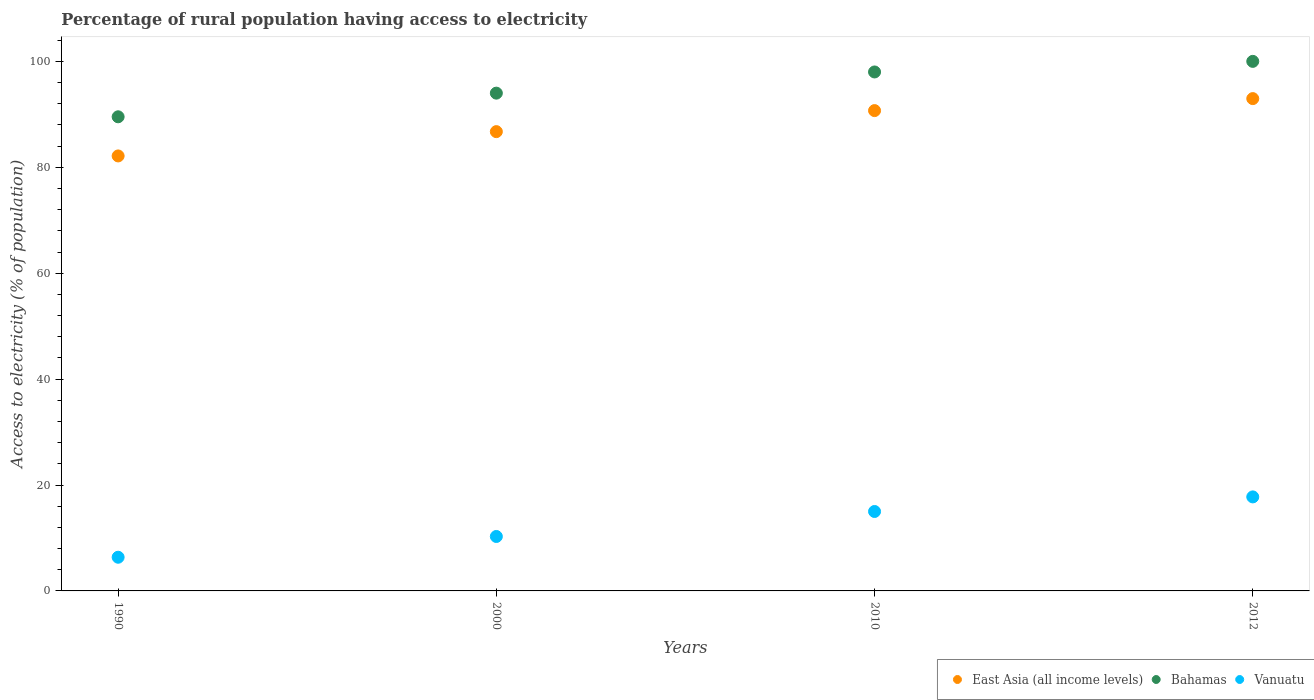How many different coloured dotlines are there?
Make the answer very short. 3. What is the percentage of rural population having access to electricity in Bahamas in 2000?
Make the answer very short. 94. Across all years, what is the maximum percentage of rural population having access to electricity in Vanuatu?
Your answer should be very brief. 17.75. Across all years, what is the minimum percentage of rural population having access to electricity in Bahamas?
Your response must be concise. 89.53. In which year was the percentage of rural population having access to electricity in East Asia (all income levels) minimum?
Provide a short and direct response. 1990. What is the total percentage of rural population having access to electricity in Vanuatu in the graph?
Provide a succinct answer. 49.4. What is the difference between the percentage of rural population having access to electricity in Bahamas in 1990 and that in 2010?
Keep it short and to the point. -8.47. What is the difference between the percentage of rural population having access to electricity in Bahamas in 2012 and the percentage of rural population having access to electricity in Vanuatu in 2010?
Make the answer very short. 85. What is the average percentage of rural population having access to electricity in Bahamas per year?
Offer a very short reply. 95.38. In the year 1990, what is the difference between the percentage of rural population having access to electricity in East Asia (all income levels) and percentage of rural population having access to electricity in Bahamas?
Provide a succinct answer. -7.39. In how many years, is the percentage of rural population having access to electricity in Vanuatu greater than 40 %?
Your answer should be compact. 0. What is the ratio of the percentage of rural population having access to electricity in East Asia (all income levels) in 2010 to that in 2012?
Provide a succinct answer. 0.98. Is the difference between the percentage of rural population having access to electricity in East Asia (all income levels) in 2000 and 2010 greater than the difference between the percentage of rural population having access to electricity in Bahamas in 2000 and 2010?
Ensure brevity in your answer.  Yes. What is the difference between the highest and the second highest percentage of rural population having access to electricity in Vanuatu?
Offer a very short reply. 2.75. What is the difference between the highest and the lowest percentage of rural population having access to electricity in Bahamas?
Ensure brevity in your answer.  10.47. Is the sum of the percentage of rural population having access to electricity in Vanuatu in 2000 and 2012 greater than the maximum percentage of rural population having access to electricity in Bahamas across all years?
Your answer should be compact. No. Does the percentage of rural population having access to electricity in Vanuatu monotonically increase over the years?
Offer a terse response. Yes. How many dotlines are there?
Ensure brevity in your answer.  3. How many years are there in the graph?
Offer a terse response. 4. What is the difference between two consecutive major ticks on the Y-axis?
Your response must be concise. 20. Are the values on the major ticks of Y-axis written in scientific E-notation?
Your response must be concise. No. Does the graph contain any zero values?
Give a very brief answer. No. Does the graph contain grids?
Provide a succinct answer. No. Where does the legend appear in the graph?
Your answer should be very brief. Bottom right. What is the title of the graph?
Your answer should be very brief. Percentage of rural population having access to electricity. Does "Djibouti" appear as one of the legend labels in the graph?
Your response must be concise. No. What is the label or title of the Y-axis?
Make the answer very short. Access to electricity (% of population). What is the Access to electricity (% of population) of East Asia (all income levels) in 1990?
Your answer should be compact. 82.14. What is the Access to electricity (% of population) in Bahamas in 1990?
Ensure brevity in your answer.  89.53. What is the Access to electricity (% of population) of Vanuatu in 1990?
Provide a short and direct response. 6.36. What is the Access to electricity (% of population) of East Asia (all income levels) in 2000?
Your answer should be compact. 86.73. What is the Access to electricity (% of population) of Bahamas in 2000?
Offer a terse response. 94. What is the Access to electricity (% of population) of Vanuatu in 2000?
Give a very brief answer. 10.28. What is the Access to electricity (% of population) in East Asia (all income levels) in 2010?
Provide a short and direct response. 90.7. What is the Access to electricity (% of population) in Bahamas in 2010?
Give a very brief answer. 98. What is the Access to electricity (% of population) of East Asia (all income levels) in 2012?
Ensure brevity in your answer.  92.97. What is the Access to electricity (% of population) in Bahamas in 2012?
Offer a terse response. 100. What is the Access to electricity (% of population) of Vanuatu in 2012?
Your answer should be compact. 17.75. Across all years, what is the maximum Access to electricity (% of population) of East Asia (all income levels)?
Your answer should be compact. 92.97. Across all years, what is the maximum Access to electricity (% of population) in Vanuatu?
Your response must be concise. 17.75. Across all years, what is the minimum Access to electricity (% of population) in East Asia (all income levels)?
Offer a terse response. 82.14. Across all years, what is the minimum Access to electricity (% of population) in Bahamas?
Ensure brevity in your answer.  89.53. Across all years, what is the minimum Access to electricity (% of population) in Vanuatu?
Keep it short and to the point. 6.36. What is the total Access to electricity (% of population) in East Asia (all income levels) in the graph?
Your answer should be compact. 352.54. What is the total Access to electricity (% of population) of Bahamas in the graph?
Your answer should be very brief. 381.53. What is the total Access to electricity (% of population) of Vanuatu in the graph?
Make the answer very short. 49.4. What is the difference between the Access to electricity (% of population) of East Asia (all income levels) in 1990 and that in 2000?
Provide a succinct answer. -4.59. What is the difference between the Access to electricity (% of population) of Bahamas in 1990 and that in 2000?
Your response must be concise. -4.47. What is the difference between the Access to electricity (% of population) of Vanuatu in 1990 and that in 2000?
Provide a succinct answer. -3.92. What is the difference between the Access to electricity (% of population) of East Asia (all income levels) in 1990 and that in 2010?
Ensure brevity in your answer.  -8.56. What is the difference between the Access to electricity (% of population) in Bahamas in 1990 and that in 2010?
Make the answer very short. -8.47. What is the difference between the Access to electricity (% of population) of Vanuatu in 1990 and that in 2010?
Give a very brief answer. -8.64. What is the difference between the Access to electricity (% of population) in East Asia (all income levels) in 1990 and that in 2012?
Provide a short and direct response. -10.83. What is the difference between the Access to electricity (% of population) of Bahamas in 1990 and that in 2012?
Ensure brevity in your answer.  -10.47. What is the difference between the Access to electricity (% of population) in Vanuatu in 1990 and that in 2012?
Provide a short and direct response. -11.39. What is the difference between the Access to electricity (% of population) of East Asia (all income levels) in 2000 and that in 2010?
Offer a very short reply. -3.97. What is the difference between the Access to electricity (% of population) in Bahamas in 2000 and that in 2010?
Your response must be concise. -4. What is the difference between the Access to electricity (% of population) of Vanuatu in 2000 and that in 2010?
Keep it short and to the point. -4.72. What is the difference between the Access to electricity (% of population) of East Asia (all income levels) in 2000 and that in 2012?
Your response must be concise. -6.24. What is the difference between the Access to electricity (% of population) of Vanuatu in 2000 and that in 2012?
Your answer should be compact. -7.47. What is the difference between the Access to electricity (% of population) in East Asia (all income levels) in 2010 and that in 2012?
Give a very brief answer. -2.27. What is the difference between the Access to electricity (% of population) in Bahamas in 2010 and that in 2012?
Provide a succinct answer. -2. What is the difference between the Access to electricity (% of population) of Vanuatu in 2010 and that in 2012?
Give a very brief answer. -2.75. What is the difference between the Access to electricity (% of population) of East Asia (all income levels) in 1990 and the Access to electricity (% of population) of Bahamas in 2000?
Make the answer very short. -11.86. What is the difference between the Access to electricity (% of population) of East Asia (all income levels) in 1990 and the Access to electricity (% of population) of Vanuatu in 2000?
Offer a very short reply. 71.86. What is the difference between the Access to electricity (% of population) of Bahamas in 1990 and the Access to electricity (% of population) of Vanuatu in 2000?
Your answer should be compact. 79.25. What is the difference between the Access to electricity (% of population) in East Asia (all income levels) in 1990 and the Access to electricity (% of population) in Bahamas in 2010?
Your answer should be very brief. -15.86. What is the difference between the Access to electricity (% of population) in East Asia (all income levels) in 1990 and the Access to electricity (% of population) in Vanuatu in 2010?
Provide a succinct answer. 67.14. What is the difference between the Access to electricity (% of population) of Bahamas in 1990 and the Access to electricity (% of population) of Vanuatu in 2010?
Offer a terse response. 74.53. What is the difference between the Access to electricity (% of population) in East Asia (all income levels) in 1990 and the Access to electricity (% of population) in Bahamas in 2012?
Your answer should be compact. -17.86. What is the difference between the Access to electricity (% of population) in East Asia (all income levels) in 1990 and the Access to electricity (% of population) in Vanuatu in 2012?
Offer a very short reply. 64.39. What is the difference between the Access to electricity (% of population) of Bahamas in 1990 and the Access to electricity (% of population) of Vanuatu in 2012?
Ensure brevity in your answer.  71.78. What is the difference between the Access to electricity (% of population) in East Asia (all income levels) in 2000 and the Access to electricity (% of population) in Bahamas in 2010?
Keep it short and to the point. -11.27. What is the difference between the Access to electricity (% of population) in East Asia (all income levels) in 2000 and the Access to electricity (% of population) in Vanuatu in 2010?
Your response must be concise. 71.73. What is the difference between the Access to electricity (% of population) in Bahamas in 2000 and the Access to electricity (% of population) in Vanuatu in 2010?
Your answer should be very brief. 79. What is the difference between the Access to electricity (% of population) of East Asia (all income levels) in 2000 and the Access to electricity (% of population) of Bahamas in 2012?
Offer a terse response. -13.27. What is the difference between the Access to electricity (% of population) of East Asia (all income levels) in 2000 and the Access to electricity (% of population) of Vanuatu in 2012?
Offer a very short reply. 68.98. What is the difference between the Access to electricity (% of population) in Bahamas in 2000 and the Access to electricity (% of population) in Vanuatu in 2012?
Offer a terse response. 76.25. What is the difference between the Access to electricity (% of population) of East Asia (all income levels) in 2010 and the Access to electricity (% of population) of Bahamas in 2012?
Provide a succinct answer. -9.3. What is the difference between the Access to electricity (% of population) in East Asia (all income levels) in 2010 and the Access to electricity (% of population) in Vanuatu in 2012?
Your answer should be very brief. 72.95. What is the difference between the Access to electricity (% of population) of Bahamas in 2010 and the Access to electricity (% of population) of Vanuatu in 2012?
Make the answer very short. 80.25. What is the average Access to electricity (% of population) of East Asia (all income levels) per year?
Keep it short and to the point. 88.14. What is the average Access to electricity (% of population) in Bahamas per year?
Provide a succinct answer. 95.38. What is the average Access to electricity (% of population) in Vanuatu per year?
Provide a succinct answer. 12.35. In the year 1990, what is the difference between the Access to electricity (% of population) in East Asia (all income levels) and Access to electricity (% of population) in Bahamas?
Offer a very short reply. -7.39. In the year 1990, what is the difference between the Access to electricity (% of population) in East Asia (all income levels) and Access to electricity (% of population) in Vanuatu?
Offer a terse response. 75.78. In the year 1990, what is the difference between the Access to electricity (% of population) of Bahamas and Access to electricity (% of population) of Vanuatu?
Offer a very short reply. 83.17. In the year 2000, what is the difference between the Access to electricity (% of population) in East Asia (all income levels) and Access to electricity (% of population) in Bahamas?
Provide a short and direct response. -7.27. In the year 2000, what is the difference between the Access to electricity (% of population) in East Asia (all income levels) and Access to electricity (% of population) in Vanuatu?
Provide a succinct answer. 76.45. In the year 2000, what is the difference between the Access to electricity (% of population) in Bahamas and Access to electricity (% of population) in Vanuatu?
Offer a very short reply. 83.72. In the year 2010, what is the difference between the Access to electricity (% of population) of East Asia (all income levels) and Access to electricity (% of population) of Bahamas?
Provide a short and direct response. -7.3. In the year 2010, what is the difference between the Access to electricity (% of population) in East Asia (all income levels) and Access to electricity (% of population) in Vanuatu?
Provide a succinct answer. 75.7. In the year 2010, what is the difference between the Access to electricity (% of population) of Bahamas and Access to electricity (% of population) of Vanuatu?
Your answer should be compact. 83. In the year 2012, what is the difference between the Access to electricity (% of population) of East Asia (all income levels) and Access to electricity (% of population) of Bahamas?
Make the answer very short. -7.03. In the year 2012, what is the difference between the Access to electricity (% of population) in East Asia (all income levels) and Access to electricity (% of population) in Vanuatu?
Provide a short and direct response. 75.21. In the year 2012, what is the difference between the Access to electricity (% of population) in Bahamas and Access to electricity (% of population) in Vanuatu?
Offer a terse response. 82.25. What is the ratio of the Access to electricity (% of population) in East Asia (all income levels) in 1990 to that in 2000?
Keep it short and to the point. 0.95. What is the ratio of the Access to electricity (% of population) of Bahamas in 1990 to that in 2000?
Your answer should be compact. 0.95. What is the ratio of the Access to electricity (% of population) in Vanuatu in 1990 to that in 2000?
Give a very brief answer. 0.62. What is the ratio of the Access to electricity (% of population) of East Asia (all income levels) in 1990 to that in 2010?
Provide a succinct answer. 0.91. What is the ratio of the Access to electricity (% of population) of Bahamas in 1990 to that in 2010?
Offer a very short reply. 0.91. What is the ratio of the Access to electricity (% of population) in Vanuatu in 1990 to that in 2010?
Give a very brief answer. 0.42. What is the ratio of the Access to electricity (% of population) of East Asia (all income levels) in 1990 to that in 2012?
Ensure brevity in your answer.  0.88. What is the ratio of the Access to electricity (% of population) of Bahamas in 1990 to that in 2012?
Ensure brevity in your answer.  0.9. What is the ratio of the Access to electricity (% of population) of Vanuatu in 1990 to that in 2012?
Offer a terse response. 0.36. What is the ratio of the Access to electricity (% of population) of East Asia (all income levels) in 2000 to that in 2010?
Your answer should be compact. 0.96. What is the ratio of the Access to electricity (% of population) of Bahamas in 2000 to that in 2010?
Your answer should be very brief. 0.96. What is the ratio of the Access to electricity (% of population) of Vanuatu in 2000 to that in 2010?
Your answer should be compact. 0.69. What is the ratio of the Access to electricity (% of population) of East Asia (all income levels) in 2000 to that in 2012?
Offer a terse response. 0.93. What is the ratio of the Access to electricity (% of population) of Bahamas in 2000 to that in 2012?
Your answer should be very brief. 0.94. What is the ratio of the Access to electricity (% of population) in Vanuatu in 2000 to that in 2012?
Offer a terse response. 0.58. What is the ratio of the Access to electricity (% of population) in East Asia (all income levels) in 2010 to that in 2012?
Your answer should be very brief. 0.98. What is the ratio of the Access to electricity (% of population) in Bahamas in 2010 to that in 2012?
Offer a very short reply. 0.98. What is the ratio of the Access to electricity (% of population) in Vanuatu in 2010 to that in 2012?
Offer a terse response. 0.84. What is the difference between the highest and the second highest Access to electricity (% of population) in East Asia (all income levels)?
Your answer should be very brief. 2.27. What is the difference between the highest and the second highest Access to electricity (% of population) in Bahamas?
Ensure brevity in your answer.  2. What is the difference between the highest and the second highest Access to electricity (% of population) in Vanuatu?
Offer a very short reply. 2.75. What is the difference between the highest and the lowest Access to electricity (% of population) of East Asia (all income levels)?
Your answer should be compact. 10.83. What is the difference between the highest and the lowest Access to electricity (% of population) of Bahamas?
Provide a succinct answer. 10.47. What is the difference between the highest and the lowest Access to electricity (% of population) in Vanuatu?
Give a very brief answer. 11.39. 